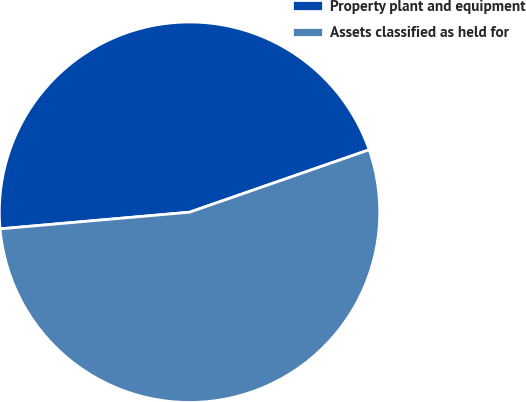Convert chart. <chart><loc_0><loc_0><loc_500><loc_500><pie_chart><fcel>Property plant and equipment<fcel>Assets classified as held for<nl><fcel>46.07%<fcel>53.93%<nl></chart> 